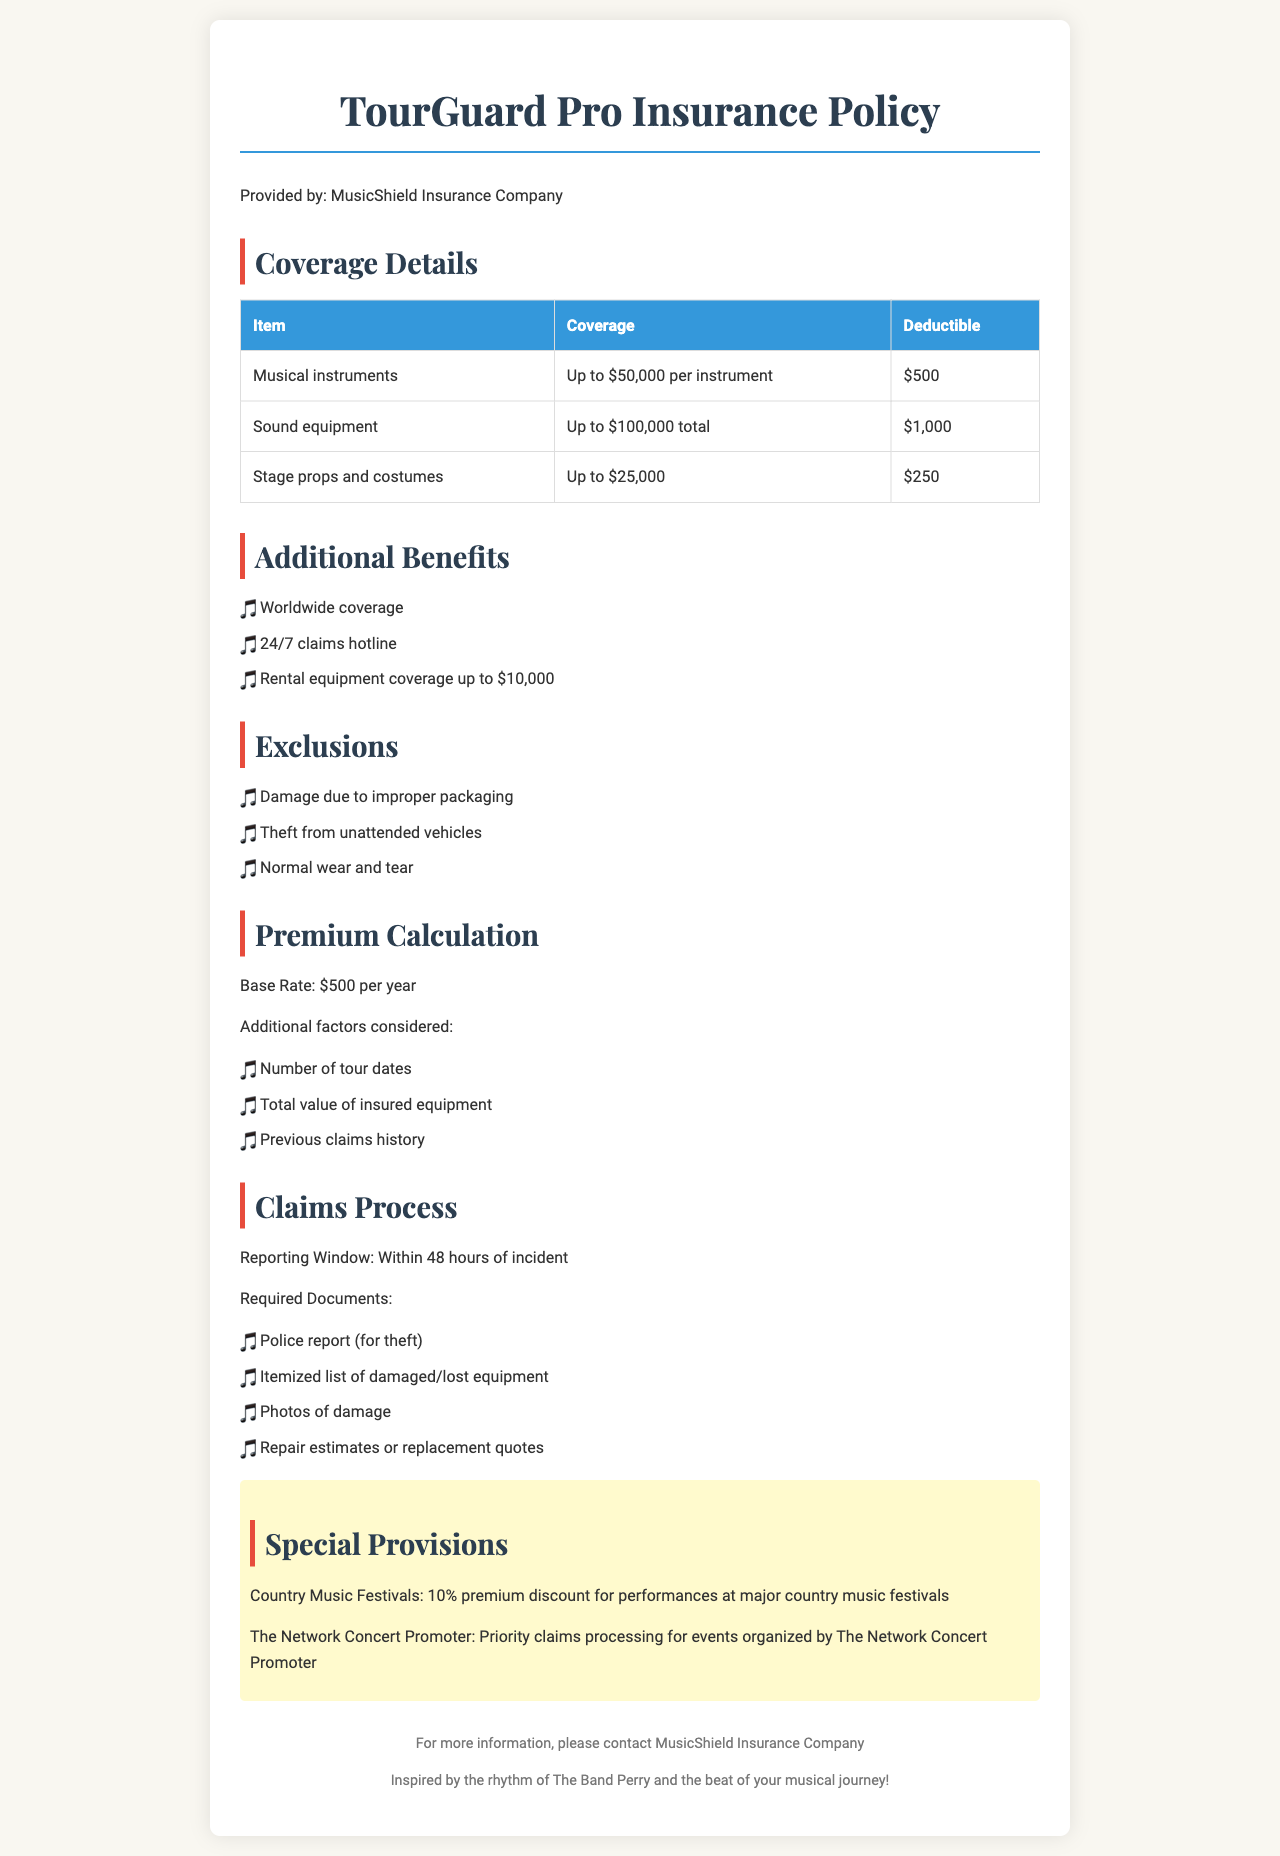What is the maximum coverage for musical instruments? The maximum coverage for musical instruments is listed as up to $50,000 per instrument in the coverage details.
Answer: Up to $50,000 per instrument What is the deductible for sound equipment? The deductible for sound equipment can be found in the coverage details, which states it is $1,000.
Answer: $1,000 What additional benefit allows coverage for rental equipment? The document mentions rental equipment coverage as one of the additional benefits.
Answer: Rental equipment coverage up to $10,000 What is the reporting window for claims? The reporting window for claims is specified as within 48 hours of the incident.
Answer: Within 48 hours Which exclusions mention theft-related incidents? One of the exclusions states "Theft from unattended vehicles" which relates to theft.
Answer: Theft from unattended vehicles What type of discount is available for performances at country music festivals? The special provisions section mentions a 10% premium discount for performances at major country music festivals.
Answer: 10% premium discount What is the base rate for this insurance policy per year? According to the premium calculation section, the base rate is $500 per year.
Answer: $500 per year Who is eligible for priority claims processing? The special provisions indicate that priority claims processing applies to events organized by The Network Concert Promoter.
Answer: The Network Concert Promoter What is required for theft claims documentation? The claims process specifies that a police report is required for theft claims.
Answer: Police report 